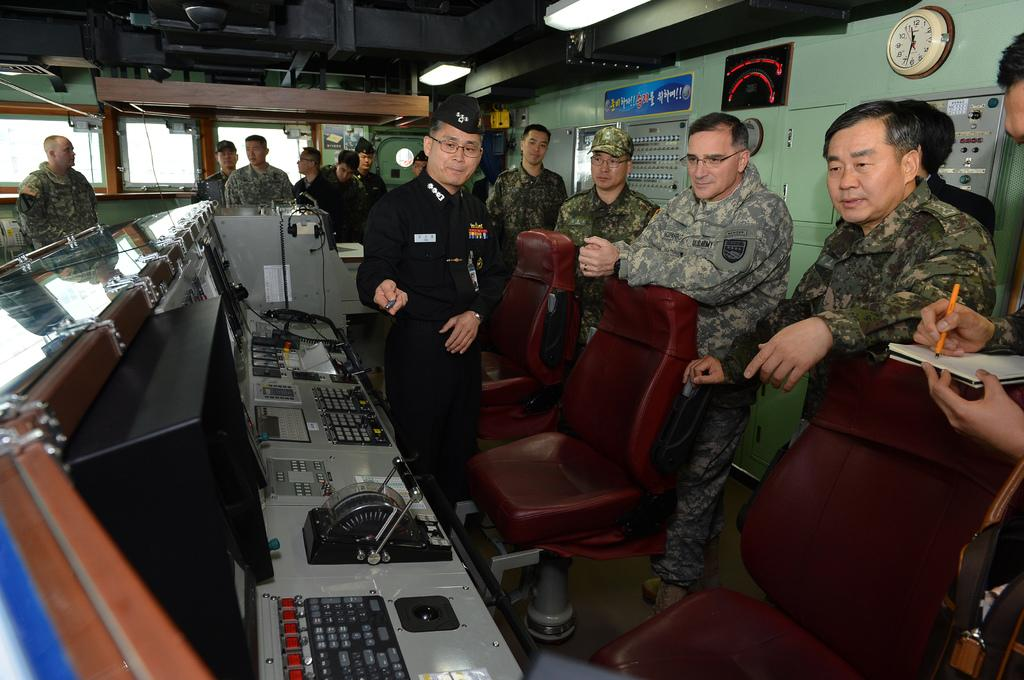What can be seen in the image involving people? There are people standing in the image. What object in the image can be used to tell time? There is a clock in the image. What type of furniture is present in the image? There are chairs in the image. What type of equipment can be seen in the image? There is electrical equipment in the image. Can you see any kites flying in the image? There is no mention of kites in the image, so we cannot determine if any are present. Is there a trampoline visible in the image? There is no mention of a trampoline in the image, so we cannot determine if one is present. 